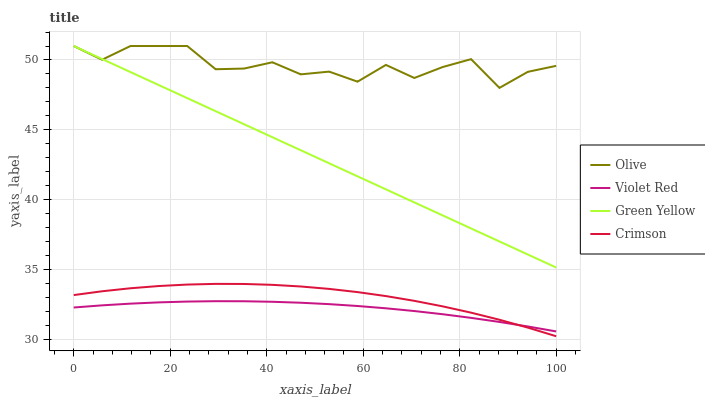Does Violet Red have the minimum area under the curve?
Answer yes or no. Yes. Does Olive have the maximum area under the curve?
Answer yes or no. Yes. Does Crimson have the minimum area under the curve?
Answer yes or no. No. Does Crimson have the maximum area under the curve?
Answer yes or no. No. Is Green Yellow the smoothest?
Answer yes or no. Yes. Is Olive the roughest?
Answer yes or no. Yes. Is Crimson the smoothest?
Answer yes or no. No. Is Crimson the roughest?
Answer yes or no. No. Does Crimson have the lowest value?
Answer yes or no. Yes. Does Violet Red have the lowest value?
Answer yes or no. No. Does Green Yellow have the highest value?
Answer yes or no. Yes. Does Crimson have the highest value?
Answer yes or no. No. Is Violet Red less than Green Yellow?
Answer yes or no. Yes. Is Olive greater than Crimson?
Answer yes or no. Yes. Does Green Yellow intersect Olive?
Answer yes or no. Yes. Is Green Yellow less than Olive?
Answer yes or no. No. Is Green Yellow greater than Olive?
Answer yes or no. No. Does Violet Red intersect Green Yellow?
Answer yes or no. No. 